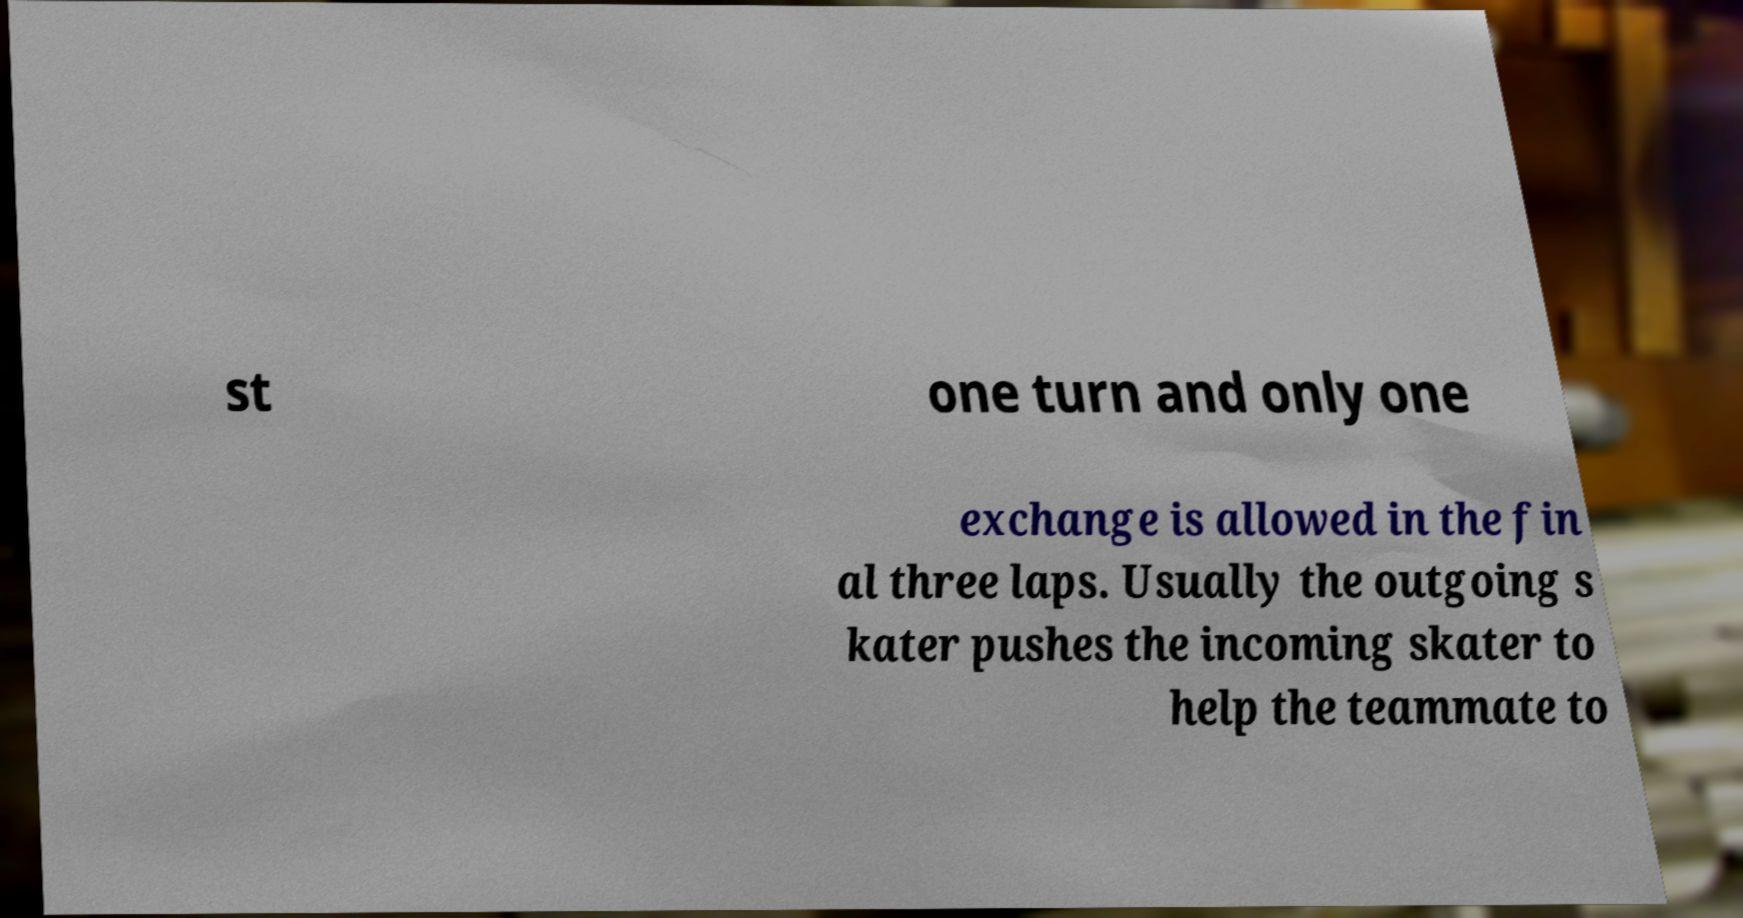For documentation purposes, I need the text within this image transcribed. Could you provide that? st one turn and only one exchange is allowed in the fin al three laps. Usually the outgoing s kater pushes the incoming skater to help the teammate to 